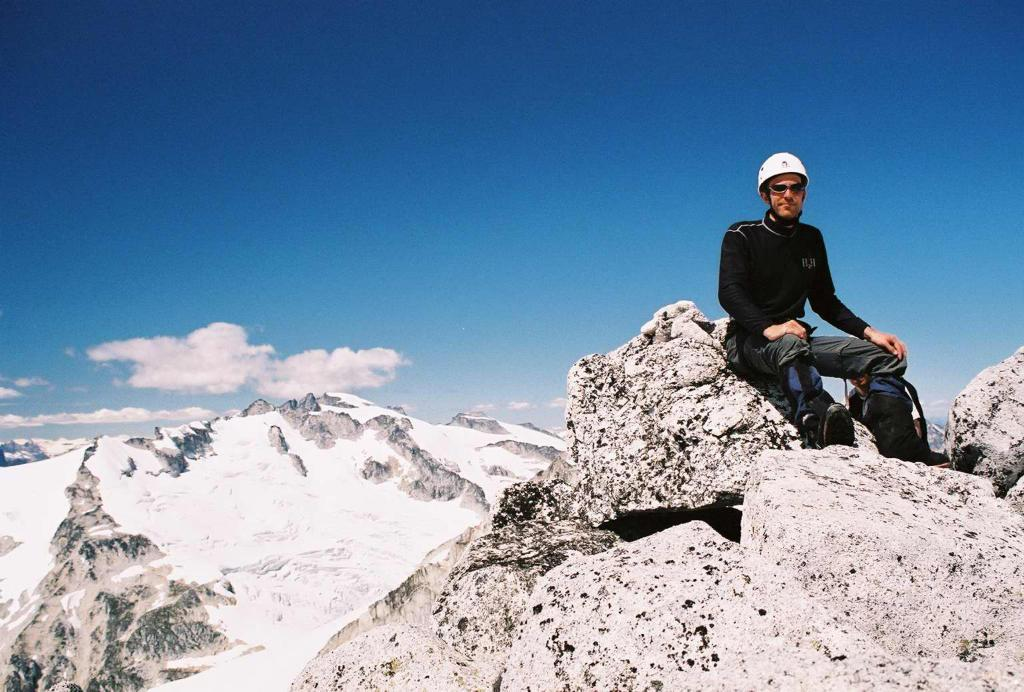What is the man in the image doing? The man is sitting on a rock in the image. What is the setting of the image? The image appears to depict a snowy mountain. What can be seen in the sky in the image? Clouds are visible in the sky in the image. What type of comb does the man use to style his hair in the image? There is no comb visible in the image, and the man's hair is not shown. Can you tell me how many houses are present in the image? There are no houses present in the image; it depicts a man sitting on a rock in a snowy mountain setting. 